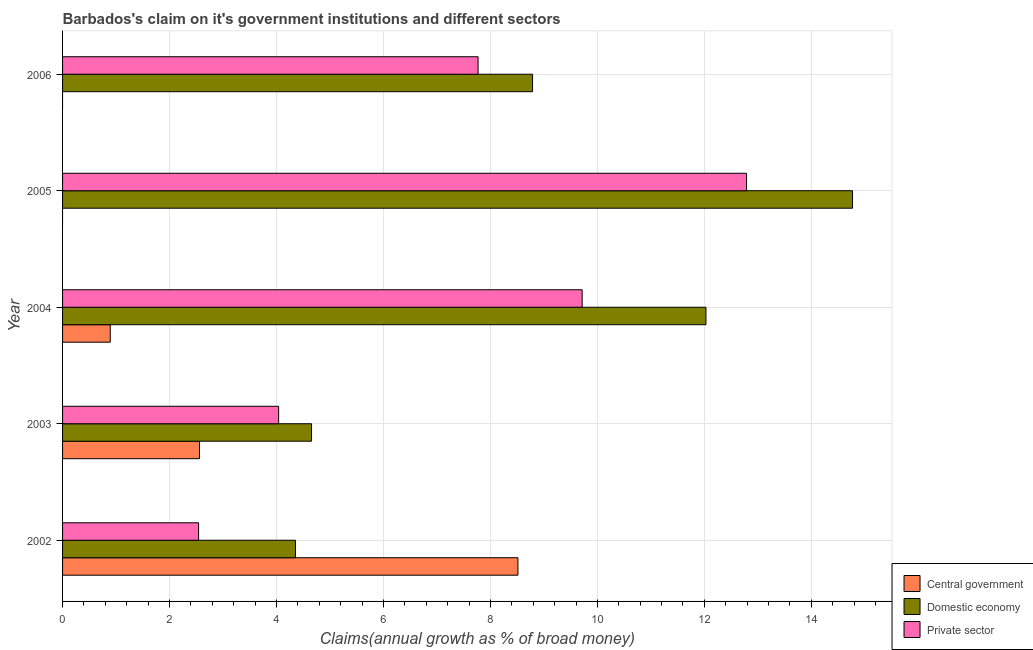Are the number of bars on each tick of the Y-axis equal?
Your answer should be very brief. No. How many bars are there on the 4th tick from the top?
Give a very brief answer. 3. What is the label of the 3rd group of bars from the top?
Offer a terse response. 2004. In how many cases, is the number of bars for a given year not equal to the number of legend labels?
Your answer should be compact. 2. What is the percentage of claim on the central government in 2006?
Keep it short and to the point. 0. Across all years, what is the maximum percentage of claim on the central government?
Your response must be concise. 8.51. Across all years, what is the minimum percentage of claim on the private sector?
Your answer should be very brief. 2.54. What is the total percentage of claim on the domestic economy in the graph?
Your answer should be compact. 44.6. What is the difference between the percentage of claim on the private sector in 2002 and that in 2005?
Your answer should be compact. -10.24. What is the difference between the percentage of claim on the central government in 2006 and the percentage of claim on the domestic economy in 2004?
Your answer should be very brief. -12.03. What is the average percentage of claim on the private sector per year?
Provide a succinct answer. 7.37. In the year 2002, what is the difference between the percentage of claim on the private sector and percentage of claim on the central government?
Your answer should be compact. -5.97. What is the ratio of the percentage of claim on the central government in 2002 to that in 2004?
Provide a succinct answer. 9.55. Is the percentage of claim on the domestic economy in 2002 less than that in 2004?
Offer a terse response. Yes. Is the difference between the percentage of claim on the domestic economy in 2003 and 2005 greater than the difference between the percentage of claim on the private sector in 2003 and 2005?
Give a very brief answer. No. What is the difference between the highest and the second highest percentage of claim on the central government?
Keep it short and to the point. 5.95. What is the difference between the highest and the lowest percentage of claim on the domestic economy?
Provide a short and direct response. 10.42. In how many years, is the percentage of claim on the central government greater than the average percentage of claim on the central government taken over all years?
Make the answer very short. 2. Is the sum of the percentage of claim on the private sector in 2002 and 2004 greater than the maximum percentage of claim on the central government across all years?
Give a very brief answer. Yes. What is the difference between two consecutive major ticks on the X-axis?
Ensure brevity in your answer.  2. Does the graph contain any zero values?
Provide a succinct answer. Yes. Does the graph contain grids?
Your answer should be very brief. Yes. What is the title of the graph?
Your answer should be very brief. Barbados's claim on it's government institutions and different sectors. Does "Negligence towards kids" appear as one of the legend labels in the graph?
Your answer should be very brief. No. What is the label or title of the X-axis?
Give a very brief answer. Claims(annual growth as % of broad money). What is the label or title of the Y-axis?
Provide a short and direct response. Year. What is the Claims(annual growth as % of broad money) in Central government in 2002?
Make the answer very short. 8.51. What is the Claims(annual growth as % of broad money) of Domestic economy in 2002?
Your answer should be very brief. 4.35. What is the Claims(annual growth as % of broad money) of Private sector in 2002?
Your answer should be compact. 2.54. What is the Claims(annual growth as % of broad money) in Central government in 2003?
Offer a terse response. 2.56. What is the Claims(annual growth as % of broad money) of Domestic economy in 2003?
Ensure brevity in your answer.  4.66. What is the Claims(annual growth as % of broad money) in Private sector in 2003?
Make the answer very short. 4.04. What is the Claims(annual growth as % of broad money) of Central government in 2004?
Provide a short and direct response. 0.89. What is the Claims(annual growth as % of broad money) in Domestic economy in 2004?
Provide a succinct answer. 12.03. What is the Claims(annual growth as % of broad money) of Private sector in 2004?
Offer a terse response. 9.72. What is the Claims(annual growth as % of broad money) in Domestic economy in 2005?
Give a very brief answer. 14.77. What is the Claims(annual growth as % of broad money) of Private sector in 2005?
Your response must be concise. 12.79. What is the Claims(annual growth as % of broad money) of Central government in 2006?
Provide a succinct answer. 0. What is the Claims(annual growth as % of broad money) in Domestic economy in 2006?
Keep it short and to the point. 8.79. What is the Claims(annual growth as % of broad money) in Private sector in 2006?
Ensure brevity in your answer.  7.77. Across all years, what is the maximum Claims(annual growth as % of broad money) of Central government?
Offer a terse response. 8.51. Across all years, what is the maximum Claims(annual growth as % of broad money) of Domestic economy?
Offer a terse response. 14.77. Across all years, what is the maximum Claims(annual growth as % of broad money) in Private sector?
Offer a terse response. 12.79. Across all years, what is the minimum Claims(annual growth as % of broad money) in Central government?
Make the answer very short. 0. Across all years, what is the minimum Claims(annual growth as % of broad money) in Domestic economy?
Ensure brevity in your answer.  4.35. Across all years, what is the minimum Claims(annual growth as % of broad money) in Private sector?
Your response must be concise. 2.54. What is the total Claims(annual growth as % of broad money) of Central government in the graph?
Provide a succinct answer. 11.97. What is the total Claims(annual growth as % of broad money) of Domestic economy in the graph?
Offer a very short reply. 44.6. What is the total Claims(annual growth as % of broad money) in Private sector in the graph?
Provide a short and direct response. 36.86. What is the difference between the Claims(annual growth as % of broad money) of Central government in 2002 and that in 2003?
Offer a terse response. 5.95. What is the difference between the Claims(annual growth as % of broad money) in Domestic economy in 2002 and that in 2003?
Provide a succinct answer. -0.3. What is the difference between the Claims(annual growth as % of broad money) in Private sector in 2002 and that in 2003?
Provide a short and direct response. -1.5. What is the difference between the Claims(annual growth as % of broad money) in Central government in 2002 and that in 2004?
Offer a very short reply. 7.62. What is the difference between the Claims(annual growth as % of broad money) in Domestic economy in 2002 and that in 2004?
Keep it short and to the point. -7.68. What is the difference between the Claims(annual growth as % of broad money) of Private sector in 2002 and that in 2004?
Offer a terse response. -7.17. What is the difference between the Claims(annual growth as % of broad money) of Domestic economy in 2002 and that in 2005?
Keep it short and to the point. -10.42. What is the difference between the Claims(annual growth as % of broad money) in Private sector in 2002 and that in 2005?
Your answer should be compact. -10.25. What is the difference between the Claims(annual growth as % of broad money) of Domestic economy in 2002 and that in 2006?
Make the answer very short. -4.43. What is the difference between the Claims(annual growth as % of broad money) in Private sector in 2002 and that in 2006?
Your answer should be compact. -5.23. What is the difference between the Claims(annual growth as % of broad money) in Central government in 2003 and that in 2004?
Ensure brevity in your answer.  1.67. What is the difference between the Claims(annual growth as % of broad money) of Domestic economy in 2003 and that in 2004?
Your answer should be very brief. -7.37. What is the difference between the Claims(annual growth as % of broad money) of Private sector in 2003 and that in 2004?
Give a very brief answer. -5.68. What is the difference between the Claims(annual growth as % of broad money) in Domestic economy in 2003 and that in 2005?
Offer a very short reply. -10.12. What is the difference between the Claims(annual growth as % of broad money) of Private sector in 2003 and that in 2005?
Ensure brevity in your answer.  -8.75. What is the difference between the Claims(annual growth as % of broad money) in Domestic economy in 2003 and that in 2006?
Give a very brief answer. -4.13. What is the difference between the Claims(annual growth as % of broad money) of Private sector in 2003 and that in 2006?
Your answer should be compact. -3.73. What is the difference between the Claims(annual growth as % of broad money) of Domestic economy in 2004 and that in 2005?
Provide a short and direct response. -2.74. What is the difference between the Claims(annual growth as % of broad money) in Private sector in 2004 and that in 2005?
Your answer should be very brief. -3.07. What is the difference between the Claims(annual growth as % of broad money) of Domestic economy in 2004 and that in 2006?
Make the answer very short. 3.24. What is the difference between the Claims(annual growth as % of broad money) of Private sector in 2004 and that in 2006?
Offer a very short reply. 1.95. What is the difference between the Claims(annual growth as % of broad money) of Domestic economy in 2005 and that in 2006?
Provide a succinct answer. 5.98. What is the difference between the Claims(annual growth as % of broad money) in Private sector in 2005 and that in 2006?
Your response must be concise. 5.02. What is the difference between the Claims(annual growth as % of broad money) of Central government in 2002 and the Claims(annual growth as % of broad money) of Domestic economy in 2003?
Your answer should be very brief. 3.86. What is the difference between the Claims(annual growth as % of broad money) in Central government in 2002 and the Claims(annual growth as % of broad money) in Private sector in 2003?
Provide a short and direct response. 4.47. What is the difference between the Claims(annual growth as % of broad money) in Domestic economy in 2002 and the Claims(annual growth as % of broad money) in Private sector in 2003?
Your response must be concise. 0.31. What is the difference between the Claims(annual growth as % of broad money) of Central government in 2002 and the Claims(annual growth as % of broad money) of Domestic economy in 2004?
Provide a succinct answer. -3.52. What is the difference between the Claims(annual growth as % of broad money) of Central government in 2002 and the Claims(annual growth as % of broad money) of Private sector in 2004?
Your response must be concise. -1.2. What is the difference between the Claims(annual growth as % of broad money) in Domestic economy in 2002 and the Claims(annual growth as % of broad money) in Private sector in 2004?
Keep it short and to the point. -5.36. What is the difference between the Claims(annual growth as % of broad money) of Central government in 2002 and the Claims(annual growth as % of broad money) of Domestic economy in 2005?
Offer a very short reply. -6.26. What is the difference between the Claims(annual growth as % of broad money) of Central government in 2002 and the Claims(annual growth as % of broad money) of Private sector in 2005?
Give a very brief answer. -4.27. What is the difference between the Claims(annual growth as % of broad money) of Domestic economy in 2002 and the Claims(annual growth as % of broad money) of Private sector in 2005?
Ensure brevity in your answer.  -8.43. What is the difference between the Claims(annual growth as % of broad money) in Central government in 2002 and the Claims(annual growth as % of broad money) in Domestic economy in 2006?
Offer a very short reply. -0.27. What is the difference between the Claims(annual growth as % of broad money) of Central government in 2002 and the Claims(annual growth as % of broad money) of Private sector in 2006?
Keep it short and to the point. 0.75. What is the difference between the Claims(annual growth as % of broad money) of Domestic economy in 2002 and the Claims(annual growth as % of broad money) of Private sector in 2006?
Your answer should be very brief. -3.41. What is the difference between the Claims(annual growth as % of broad money) of Central government in 2003 and the Claims(annual growth as % of broad money) of Domestic economy in 2004?
Make the answer very short. -9.47. What is the difference between the Claims(annual growth as % of broad money) of Central government in 2003 and the Claims(annual growth as % of broad money) of Private sector in 2004?
Your response must be concise. -7.16. What is the difference between the Claims(annual growth as % of broad money) in Domestic economy in 2003 and the Claims(annual growth as % of broad money) in Private sector in 2004?
Offer a very short reply. -5.06. What is the difference between the Claims(annual growth as % of broad money) in Central government in 2003 and the Claims(annual growth as % of broad money) in Domestic economy in 2005?
Provide a short and direct response. -12.21. What is the difference between the Claims(annual growth as % of broad money) in Central government in 2003 and the Claims(annual growth as % of broad money) in Private sector in 2005?
Provide a short and direct response. -10.23. What is the difference between the Claims(annual growth as % of broad money) of Domestic economy in 2003 and the Claims(annual growth as % of broad money) of Private sector in 2005?
Provide a short and direct response. -8.13. What is the difference between the Claims(annual growth as % of broad money) in Central government in 2003 and the Claims(annual growth as % of broad money) in Domestic economy in 2006?
Offer a terse response. -6.23. What is the difference between the Claims(annual growth as % of broad money) of Central government in 2003 and the Claims(annual growth as % of broad money) of Private sector in 2006?
Ensure brevity in your answer.  -5.21. What is the difference between the Claims(annual growth as % of broad money) in Domestic economy in 2003 and the Claims(annual growth as % of broad money) in Private sector in 2006?
Ensure brevity in your answer.  -3.11. What is the difference between the Claims(annual growth as % of broad money) of Central government in 2004 and the Claims(annual growth as % of broad money) of Domestic economy in 2005?
Your answer should be very brief. -13.88. What is the difference between the Claims(annual growth as % of broad money) of Central government in 2004 and the Claims(annual growth as % of broad money) of Private sector in 2005?
Your response must be concise. -11.9. What is the difference between the Claims(annual growth as % of broad money) of Domestic economy in 2004 and the Claims(annual growth as % of broad money) of Private sector in 2005?
Keep it short and to the point. -0.76. What is the difference between the Claims(annual growth as % of broad money) of Central government in 2004 and the Claims(annual growth as % of broad money) of Domestic economy in 2006?
Provide a succinct answer. -7.9. What is the difference between the Claims(annual growth as % of broad money) in Central government in 2004 and the Claims(annual growth as % of broad money) in Private sector in 2006?
Your answer should be compact. -6.88. What is the difference between the Claims(annual growth as % of broad money) in Domestic economy in 2004 and the Claims(annual growth as % of broad money) in Private sector in 2006?
Provide a short and direct response. 4.26. What is the difference between the Claims(annual growth as % of broad money) of Domestic economy in 2005 and the Claims(annual growth as % of broad money) of Private sector in 2006?
Give a very brief answer. 7. What is the average Claims(annual growth as % of broad money) of Central government per year?
Offer a very short reply. 2.39. What is the average Claims(annual growth as % of broad money) in Domestic economy per year?
Give a very brief answer. 8.92. What is the average Claims(annual growth as % of broad money) in Private sector per year?
Provide a short and direct response. 7.37. In the year 2002, what is the difference between the Claims(annual growth as % of broad money) in Central government and Claims(annual growth as % of broad money) in Domestic economy?
Provide a succinct answer. 4.16. In the year 2002, what is the difference between the Claims(annual growth as % of broad money) of Central government and Claims(annual growth as % of broad money) of Private sector?
Keep it short and to the point. 5.97. In the year 2002, what is the difference between the Claims(annual growth as % of broad money) of Domestic economy and Claims(annual growth as % of broad money) of Private sector?
Your response must be concise. 1.81. In the year 2003, what is the difference between the Claims(annual growth as % of broad money) of Central government and Claims(annual growth as % of broad money) of Domestic economy?
Offer a terse response. -2.1. In the year 2003, what is the difference between the Claims(annual growth as % of broad money) in Central government and Claims(annual growth as % of broad money) in Private sector?
Ensure brevity in your answer.  -1.48. In the year 2003, what is the difference between the Claims(annual growth as % of broad money) of Domestic economy and Claims(annual growth as % of broad money) of Private sector?
Provide a short and direct response. 0.62. In the year 2004, what is the difference between the Claims(annual growth as % of broad money) in Central government and Claims(annual growth as % of broad money) in Domestic economy?
Provide a succinct answer. -11.14. In the year 2004, what is the difference between the Claims(annual growth as % of broad money) in Central government and Claims(annual growth as % of broad money) in Private sector?
Provide a short and direct response. -8.82. In the year 2004, what is the difference between the Claims(annual growth as % of broad money) of Domestic economy and Claims(annual growth as % of broad money) of Private sector?
Your response must be concise. 2.31. In the year 2005, what is the difference between the Claims(annual growth as % of broad money) in Domestic economy and Claims(annual growth as % of broad money) in Private sector?
Offer a very short reply. 1.98. In the year 2006, what is the difference between the Claims(annual growth as % of broad money) in Domestic economy and Claims(annual growth as % of broad money) in Private sector?
Your answer should be compact. 1.02. What is the ratio of the Claims(annual growth as % of broad money) of Central government in 2002 to that in 2003?
Make the answer very short. 3.33. What is the ratio of the Claims(annual growth as % of broad money) in Domestic economy in 2002 to that in 2003?
Offer a terse response. 0.94. What is the ratio of the Claims(annual growth as % of broad money) of Private sector in 2002 to that in 2003?
Ensure brevity in your answer.  0.63. What is the ratio of the Claims(annual growth as % of broad money) in Central government in 2002 to that in 2004?
Ensure brevity in your answer.  9.55. What is the ratio of the Claims(annual growth as % of broad money) in Domestic economy in 2002 to that in 2004?
Your response must be concise. 0.36. What is the ratio of the Claims(annual growth as % of broad money) in Private sector in 2002 to that in 2004?
Provide a short and direct response. 0.26. What is the ratio of the Claims(annual growth as % of broad money) in Domestic economy in 2002 to that in 2005?
Ensure brevity in your answer.  0.29. What is the ratio of the Claims(annual growth as % of broad money) in Private sector in 2002 to that in 2005?
Your answer should be very brief. 0.2. What is the ratio of the Claims(annual growth as % of broad money) in Domestic economy in 2002 to that in 2006?
Make the answer very short. 0.5. What is the ratio of the Claims(annual growth as % of broad money) of Private sector in 2002 to that in 2006?
Your answer should be very brief. 0.33. What is the ratio of the Claims(annual growth as % of broad money) in Central government in 2003 to that in 2004?
Your answer should be very brief. 2.87. What is the ratio of the Claims(annual growth as % of broad money) in Domestic economy in 2003 to that in 2004?
Make the answer very short. 0.39. What is the ratio of the Claims(annual growth as % of broad money) in Private sector in 2003 to that in 2004?
Offer a terse response. 0.42. What is the ratio of the Claims(annual growth as % of broad money) of Domestic economy in 2003 to that in 2005?
Provide a succinct answer. 0.32. What is the ratio of the Claims(annual growth as % of broad money) of Private sector in 2003 to that in 2005?
Give a very brief answer. 0.32. What is the ratio of the Claims(annual growth as % of broad money) of Domestic economy in 2003 to that in 2006?
Provide a succinct answer. 0.53. What is the ratio of the Claims(annual growth as % of broad money) of Private sector in 2003 to that in 2006?
Make the answer very short. 0.52. What is the ratio of the Claims(annual growth as % of broad money) in Domestic economy in 2004 to that in 2005?
Provide a short and direct response. 0.81. What is the ratio of the Claims(annual growth as % of broad money) in Private sector in 2004 to that in 2005?
Ensure brevity in your answer.  0.76. What is the ratio of the Claims(annual growth as % of broad money) of Domestic economy in 2004 to that in 2006?
Make the answer very short. 1.37. What is the ratio of the Claims(annual growth as % of broad money) in Private sector in 2004 to that in 2006?
Make the answer very short. 1.25. What is the ratio of the Claims(annual growth as % of broad money) of Domestic economy in 2005 to that in 2006?
Give a very brief answer. 1.68. What is the ratio of the Claims(annual growth as % of broad money) of Private sector in 2005 to that in 2006?
Make the answer very short. 1.65. What is the difference between the highest and the second highest Claims(annual growth as % of broad money) of Central government?
Offer a very short reply. 5.95. What is the difference between the highest and the second highest Claims(annual growth as % of broad money) of Domestic economy?
Your answer should be very brief. 2.74. What is the difference between the highest and the second highest Claims(annual growth as % of broad money) of Private sector?
Your response must be concise. 3.07. What is the difference between the highest and the lowest Claims(annual growth as % of broad money) in Central government?
Your response must be concise. 8.51. What is the difference between the highest and the lowest Claims(annual growth as % of broad money) of Domestic economy?
Give a very brief answer. 10.42. What is the difference between the highest and the lowest Claims(annual growth as % of broad money) of Private sector?
Give a very brief answer. 10.25. 